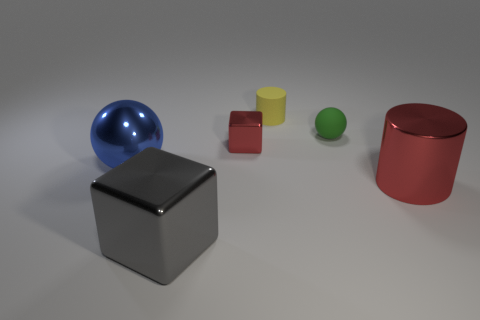Do the tiny cube and the metallic cylinder have the same color?
Provide a short and direct response. Yes. There is a large shiny thing that is to the right of the tiny green sphere; does it have the same color as the tiny cube?
Offer a very short reply. Yes. There is a metal cube that is behind the big red thing; is it the same color as the shiny object right of the green thing?
Provide a short and direct response. Yes. The sphere that is made of the same material as the large red cylinder is what color?
Your response must be concise. Blue. The small shiny thing that is the same color as the large shiny cylinder is what shape?
Keep it short and to the point. Cube. Are there the same number of green spheres left of the gray shiny object and green things that are behind the tiny red shiny thing?
Offer a very short reply. No. What shape is the big object behind the red metallic object that is right of the tiny yellow thing?
Provide a succinct answer. Sphere. There is a blue object that is the same shape as the small green thing; what is it made of?
Make the answer very short. Metal. What color is the metal sphere that is the same size as the gray cube?
Offer a very short reply. Blue. Are there an equal number of small objects to the right of the rubber cylinder and blue shiny spheres?
Offer a very short reply. Yes. 